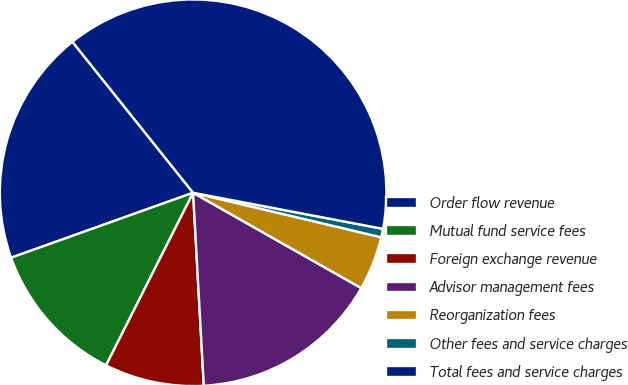<chart> <loc_0><loc_0><loc_500><loc_500><pie_chart><fcel>Order flow revenue<fcel>Mutual fund service fees<fcel>Foreign exchange revenue<fcel>Advisor management fees<fcel>Reorganization fees<fcel>Other fees and service charges<fcel>Total fees and service charges<nl><fcel>19.72%<fcel>12.11%<fcel>8.31%<fcel>15.91%<fcel>4.51%<fcel>0.71%<fcel>38.72%<nl></chart> 